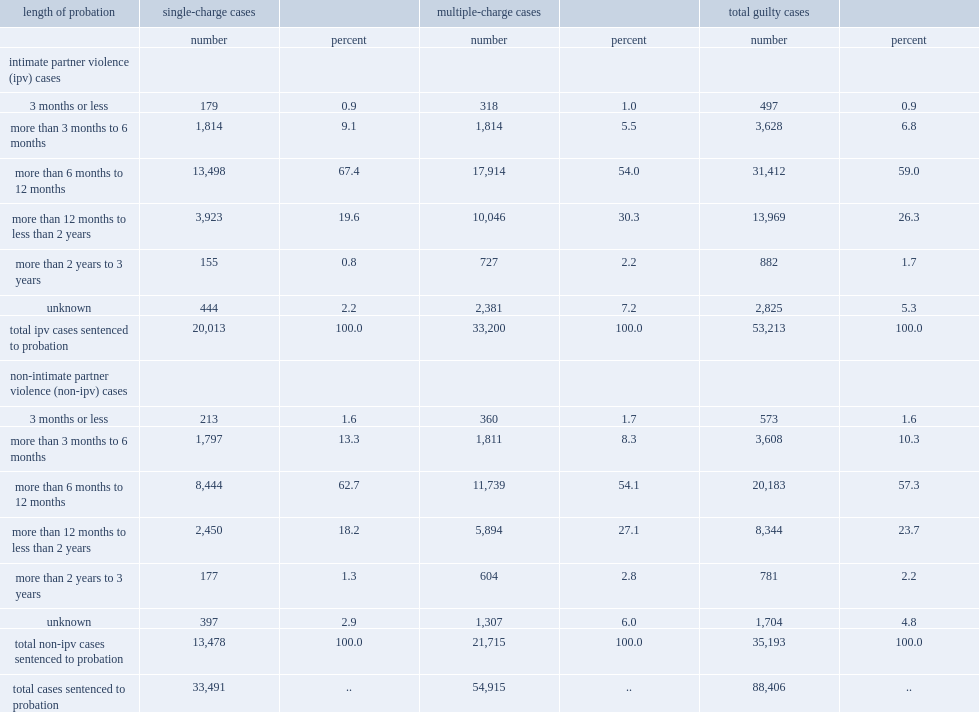What percent of accused persons in ipv cases who were sentenced to probation, which was more than six months but less than one year. 59.0. 